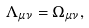<formula> <loc_0><loc_0><loc_500><loc_500>\Lambda _ { \mu \nu } = \Omega _ { \mu \nu } ,</formula> 